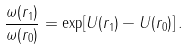<formula> <loc_0><loc_0><loc_500><loc_500>\frac { \omega ( r _ { 1 } ) } { \omega ( r _ { 0 } ) } = \exp [ U ( r _ { 1 } ) - U ( r _ { 0 } ) ] \, .</formula> 